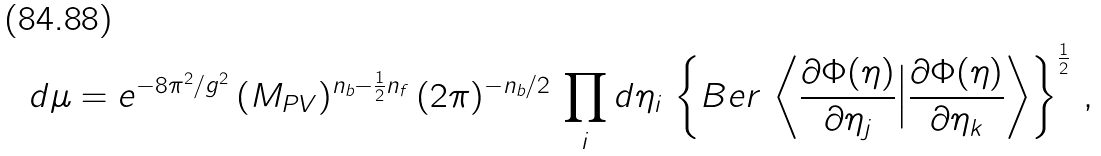Convert formula to latex. <formula><loc_0><loc_0><loc_500><loc_500>d \mu = e ^ { - 8 \pi ^ { 2 } / g ^ { 2 } } \, ( M _ { P V } ) ^ { n _ { b } - \frac { 1 } { 2 } n _ { f } } \, ( 2 \pi ) ^ { - n _ { b } / 2 } \, \prod _ { i } d \eta _ { i } \, \left \{ B e r \, \left \langle \frac { \partial \Phi ( \eta ) } { \partial \eta _ { j } } \Big | \frac { \partial \Phi ( \eta ) } { \partial \eta _ { k } } \right \rangle \right \} ^ { \frac { 1 } { 2 } } \, ,</formula> 